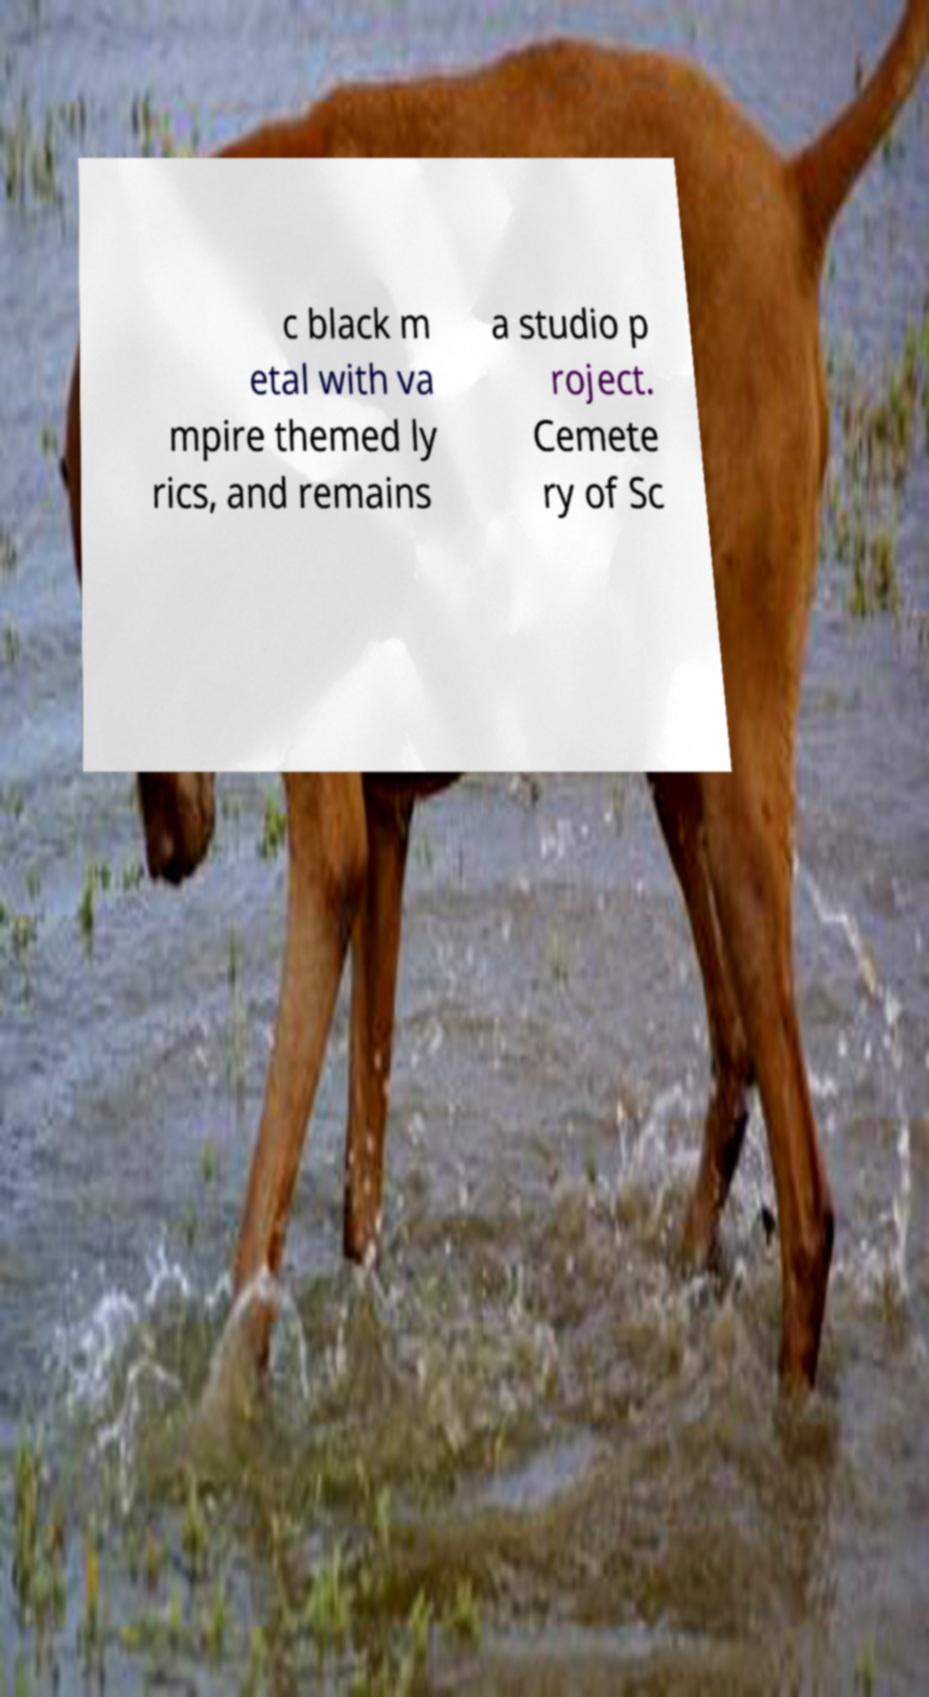For documentation purposes, I need the text within this image transcribed. Could you provide that? c black m etal with va mpire themed ly rics, and remains a studio p roject. Cemete ry of Sc 